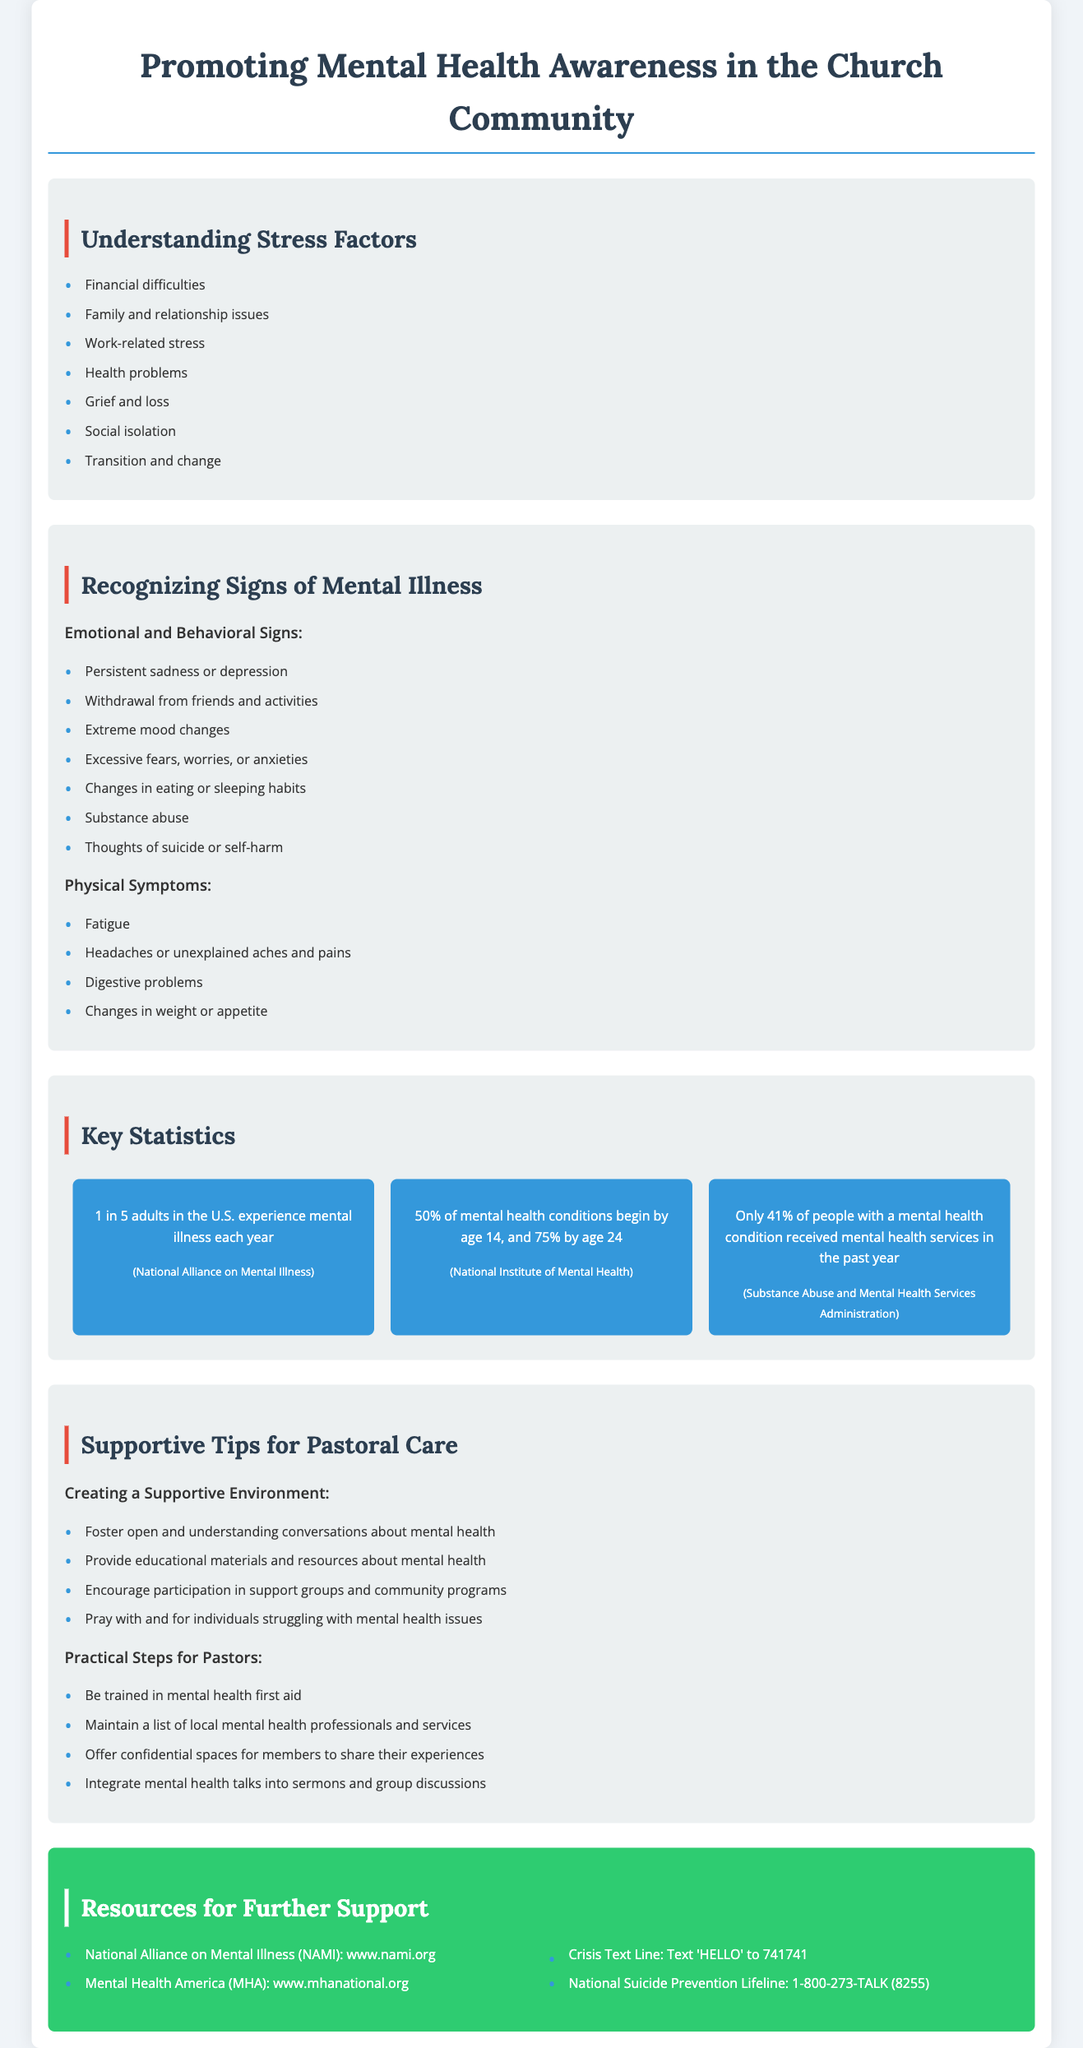What are some stress factors mentioned? The document lists various stress factors affecting individuals, such as financial difficulties and relationship issues.
Answer: Financial difficulties What percentage of adults experience mental illness each year? The document states that 1 in 5 adults in the U.S. experience mental illness each year, which translates to 20%.
Answer: 1 in 5 What is one emotional sign of mental illness? The document outlines several signs, such as persistent sadness or depression, which indicate mental illness.
Answer: Persistent sadness Which organization provides resources for mental health support? The document references multiple organizations and resources, one of which is the National Alliance on Mental Illness.
Answer: National Alliance on Mental Illness (NAMI) How many mental health conditions begin by age 14? The document provides statistics indicating that 50% of mental health conditions begin by age 14.
Answer: 50% What do pastors need to be trained in according to the document? The document suggests that pastors should be trained in mental health first aid to better support their congregants.
Answer: Mental health first aid What is a practical step for creating a supportive environment? The document mentions various actions, one of which is fostering open and understanding conversations about mental health.
Answer: Foster open conversations What resource can you text for immediate support? The document lists the Crisis Text Line, which can be contacted by texting 'HELLO' to 741741.
Answer: Text 'HELLO' to 741741 